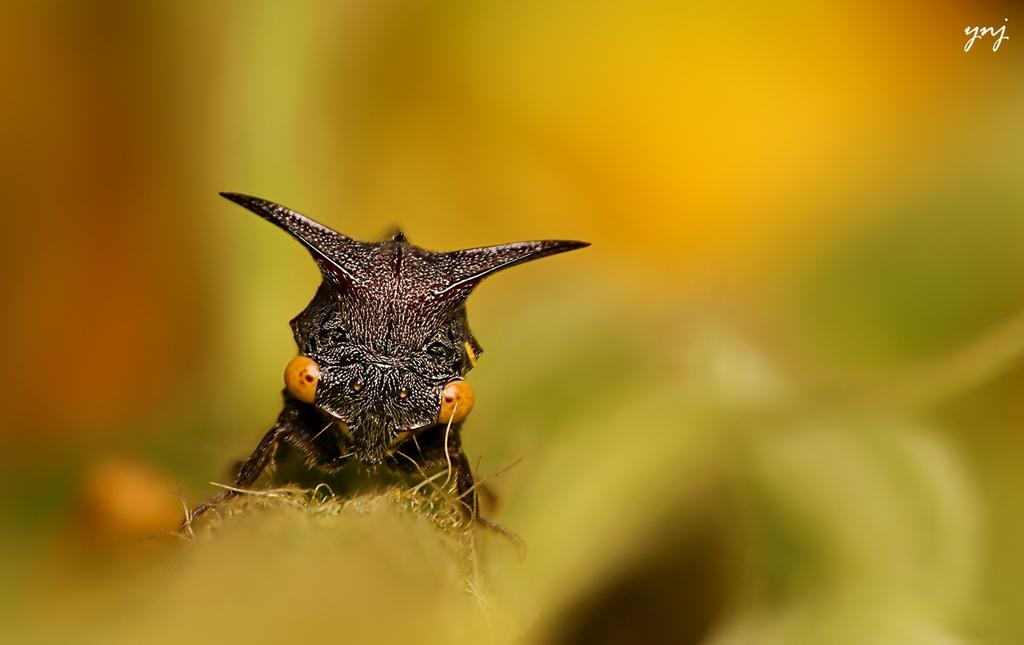What type of creature can be seen in the image? There is an insect in the image. Can you describe the background of the image? The background of the image is blurred. What type of hydrant can be seen near the seashore in the image? There is no hydrant or seashore present in the image; it only features an insect and a blurred background. 